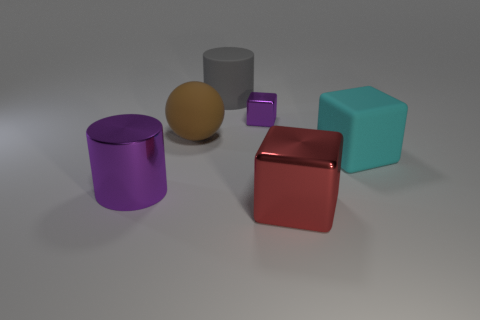What color is the cylinder that is the same material as the sphere? The cylinder sharing the same glossy, metallic material as the sphere is gray. This material gives both the cylinder and the sphere a reflective quality that shines under the light source in the image. 